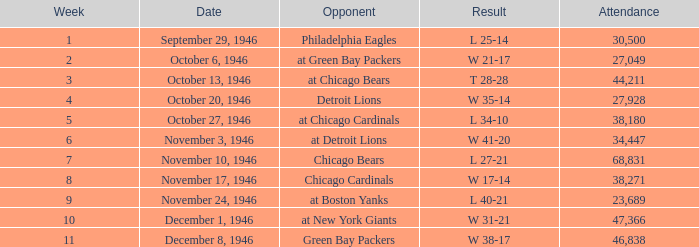What is the total attendance for all games with a final score of 35-14 in favor of the winning team? 27928.0. 